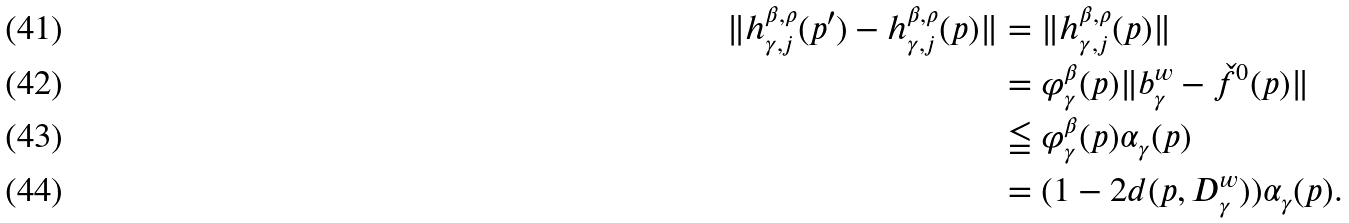Convert formula to latex. <formula><loc_0><loc_0><loc_500><loc_500>\| h _ { \gamma , j } ^ { \beta , \rho } ( p ^ { \prime } ) - h _ { \gamma , j } ^ { \beta , \rho } ( p ) \| & = \| h _ { \gamma , j } ^ { \beta , \rho } ( p ) \| \\ & = \varphi _ { \gamma } ^ { \beta } ( p ) \| b _ { \gamma } ^ { w } - \check { f } ^ { 0 } ( p ) \| \\ & \leqq \varphi _ { \gamma } ^ { \beta } ( p ) \alpha _ { \gamma } ( p ) \\ & = ( 1 - 2 d ( p , D _ { \gamma } ^ { w } ) ) \alpha _ { \gamma } ( p ) .</formula> 